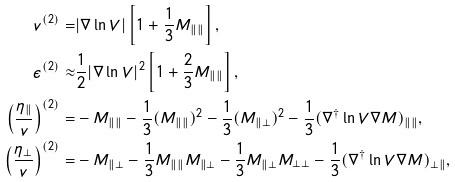<formula> <loc_0><loc_0><loc_500><loc_500>v ^ { ( 2 ) } = & | \nabla \ln V | \left [ 1 + \frac { 1 } { 3 } M _ { \| \| } \right ] , \\ \epsilon ^ { ( 2 ) } \approx & \frac { 1 } { 2 } | \nabla \ln V | ^ { 2 } \left [ 1 + \frac { 2 } { 3 } M _ { \| \| } \right ] , \\ \left ( \frac { \eta _ { \| } } { v } \right ) ^ { ( 2 ) } = & - M _ { \| \| } - \frac { 1 } { 3 } ( M _ { \| \| } ) ^ { 2 } - \frac { 1 } { 3 } ( M _ { \| \perp } ) ^ { 2 } - \frac { 1 } { 3 } ( \nabla ^ { \dag } \ln V \nabla M ) _ { \| \| } , \\ \left ( \frac { \eta _ { \perp } } { v } \right ) ^ { ( 2 ) } = & - M _ { \| \perp } - \frac { 1 } { 3 } M _ { \| \| } M _ { \| \perp } - \frac { 1 } { 3 } M _ { \| \perp } M _ { \perp \perp } - \frac { 1 } { 3 } ( \nabla ^ { \dag } \ln V \nabla M ) _ { \perp \| } ,</formula> 